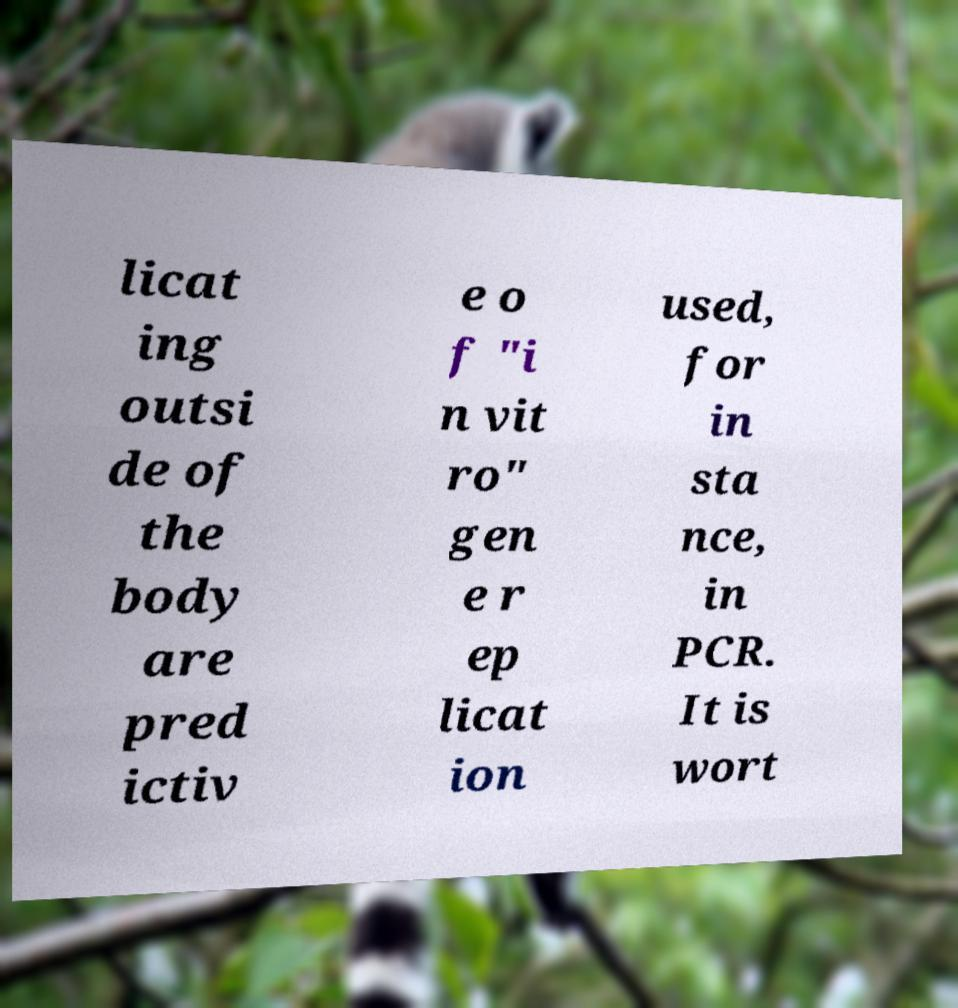Can you accurately transcribe the text from the provided image for me? licat ing outsi de of the body are pred ictiv e o f "i n vit ro" gen e r ep licat ion used, for in sta nce, in PCR. It is wort 